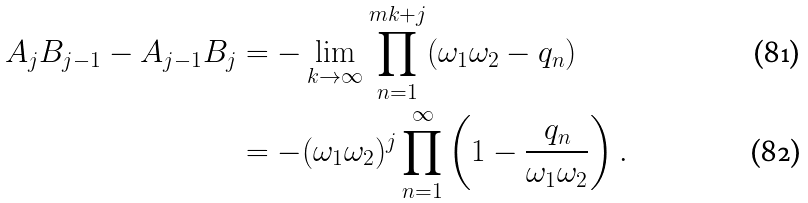Convert formula to latex. <formula><loc_0><loc_0><loc_500><loc_500>A _ { j } B _ { j - 1 } - A _ { j - 1 } B _ { j } & = - \lim _ { k \to \infty } \prod _ { n = 1 } ^ { m k + j } ( \omega _ { 1 } \omega _ { 2 } - q _ { n } ) \\ & = - ( \omega _ { 1 } \omega _ { 2 } ) ^ { j } \prod _ { n = 1 } ^ { \infty } \left ( 1 - \frac { q _ { n } } { \omega _ { 1 } \omega _ { 2 } } \right ) .</formula> 